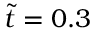Convert formula to latex. <formula><loc_0><loc_0><loc_500><loc_500>\tilde { t } = 0 . 3</formula> 